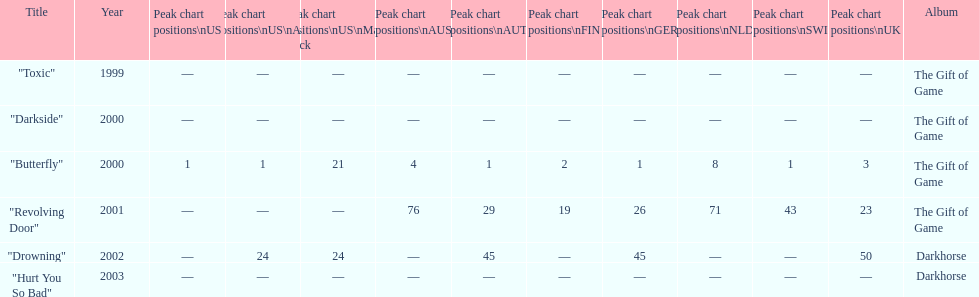By how many chart positions higher did "revolving door" peak in the uk compared to the peak position of "drowning" in the uk? 27. 